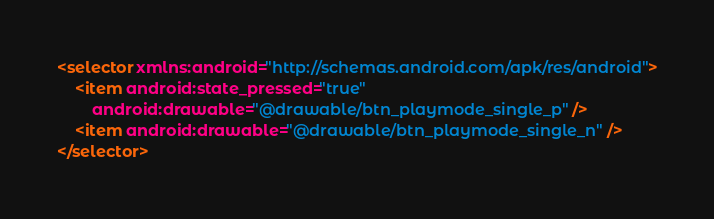Convert code to text. <code><loc_0><loc_0><loc_500><loc_500><_XML_><selector xmlns:android="http://schemas.android.com/apk/res/android">
	<item android:state_pressed="true"
		android:drawable="@drawable/btn_playmode_single_p" />
	<item android:drawable="@drawable/btn_playmode_single_n" />
</selector></code> 